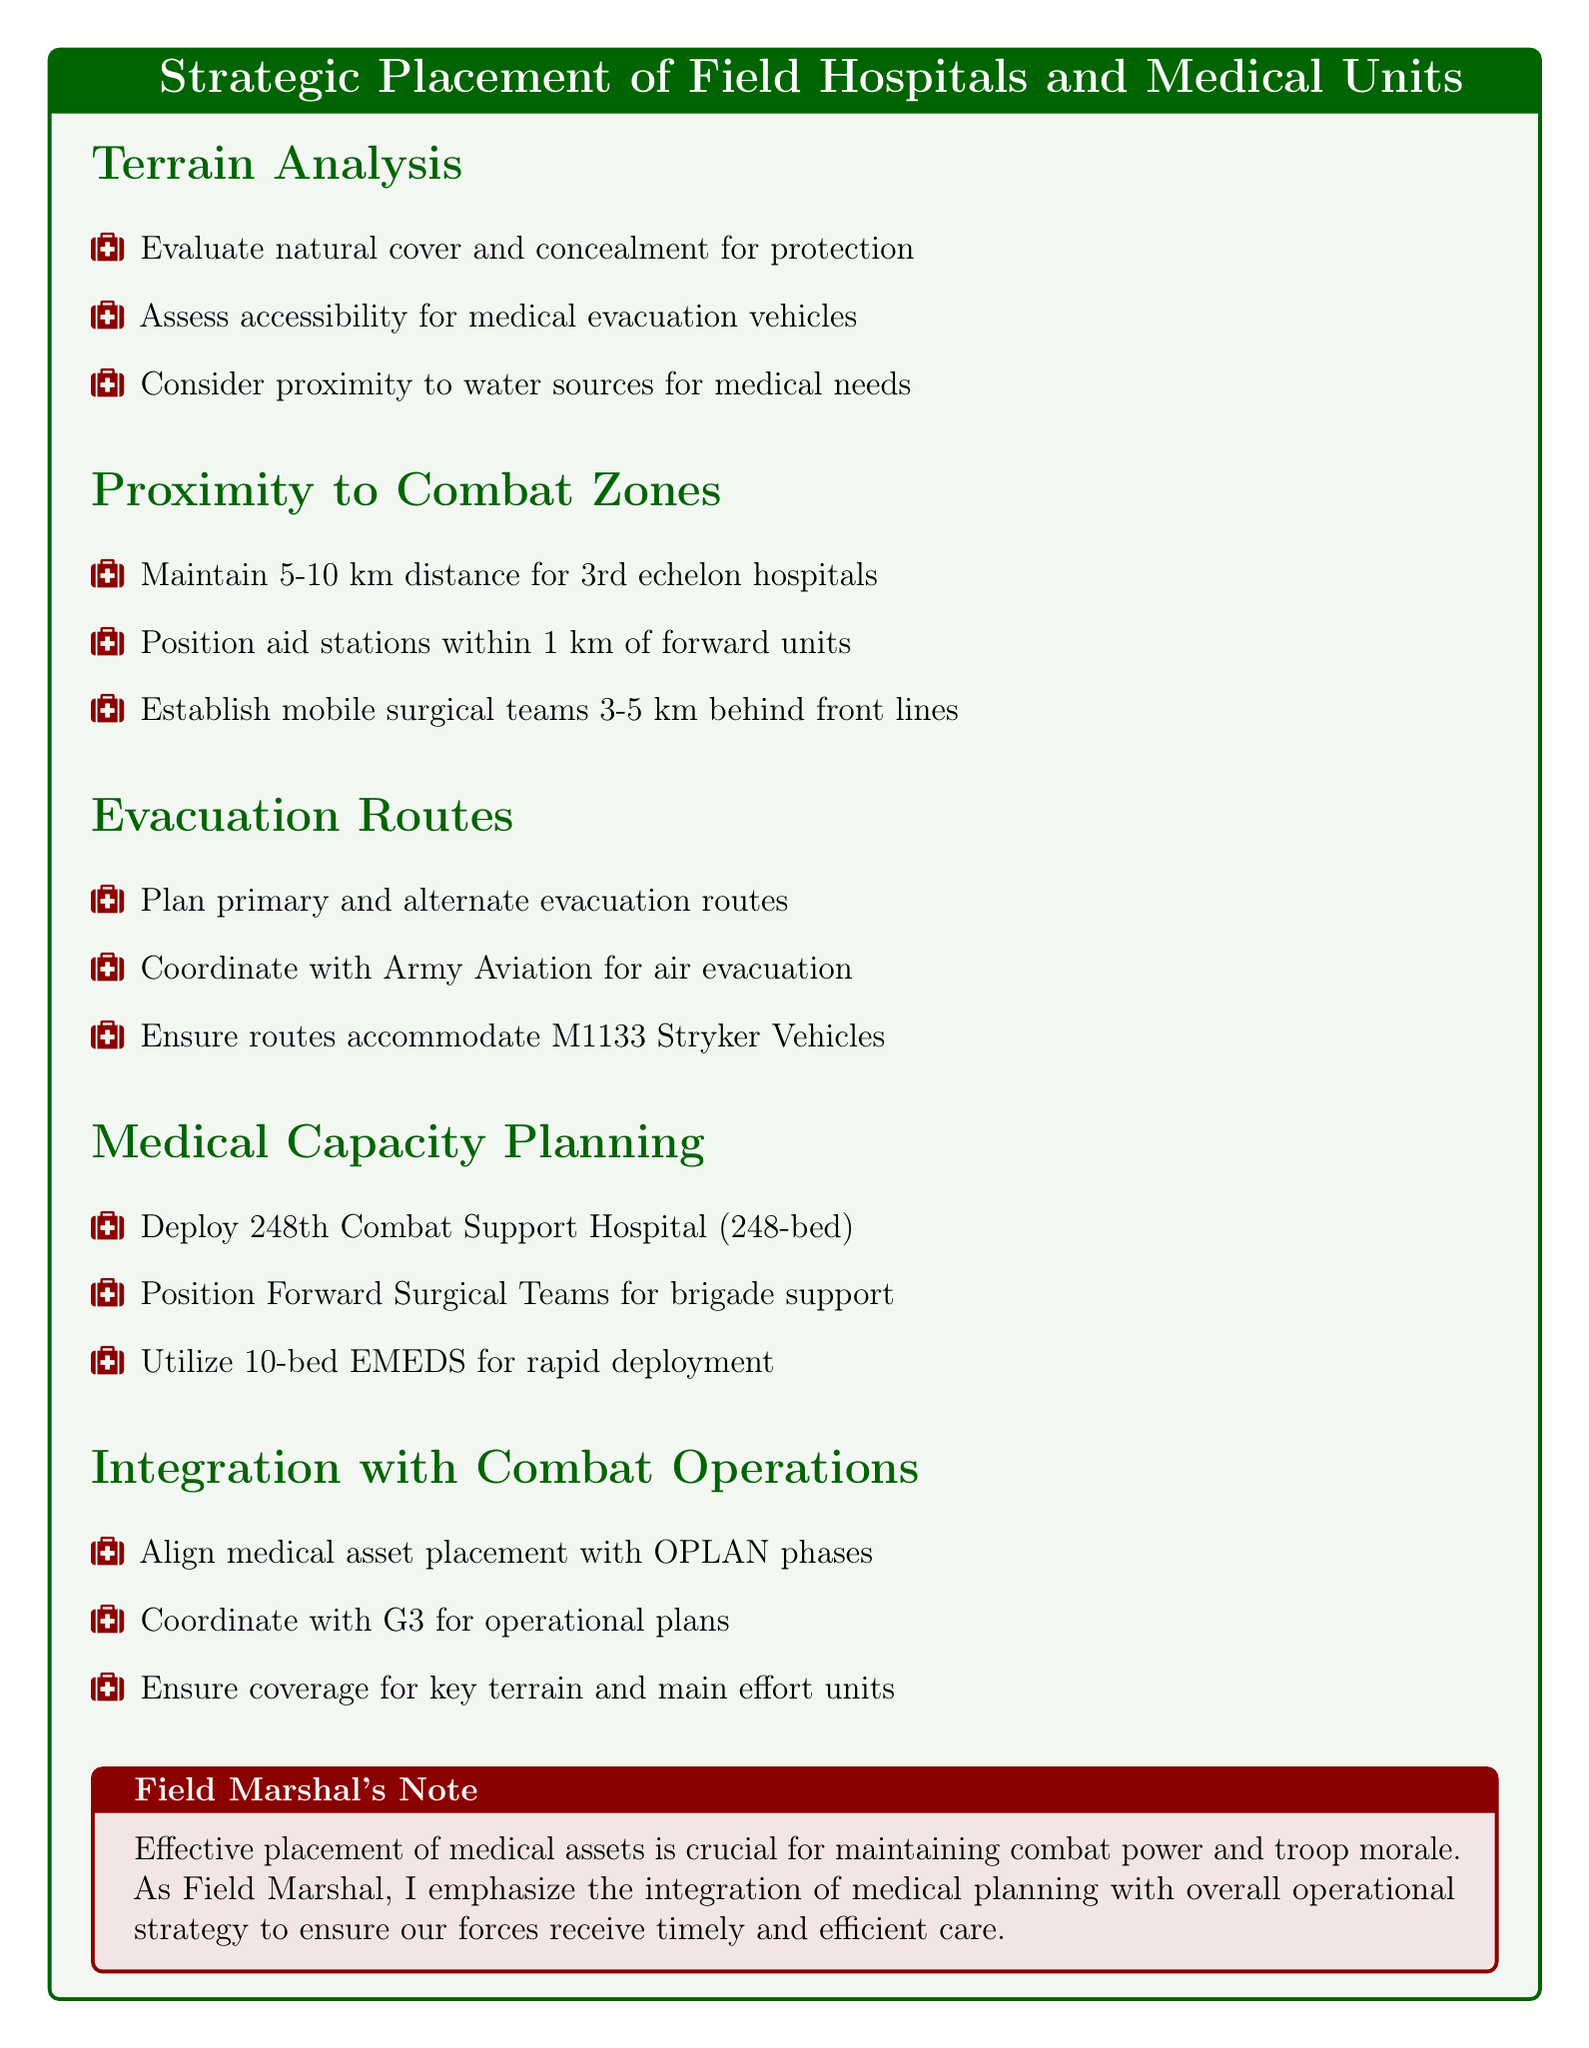What is the recommended distance for 3rd echelon hospitals? The document states that 3rd echelon hospitals should maintain a distance of 5-10 km from the front lines.
Answer: 5-10 km What is the capacity of the 248th Combat Support Hospital? The 248th Combat Support Hospital has a 248-bed capability as mentioned in the medical capacity planning section.
Answer: 248 beds Where should aid stations be positioned for immediate care? Aid stations should be positioned within 1 km of forward units for immediate care.
Answer: Within 1 km What type of vehicles should evacuation routes accommodate? The evacuation routes should be able to accommodate M1133 Stryker Medical Evacuation Vehicles as specified in the evacuation routes section.
Answer: M1133 Stryker Vehicles How far behind the front lines should mobile surgical teams be established? Mobile surgical teams should be established 3-5 km behind the front lines according to the document.
Answer: 3-5 km What medical unit supports brigade combat teams? Forward Surgical Teams (FST) are positioned to support brigade combat teams as indicated in the medical capacity planning section.
Answer: Forward Surgical Teams (FST) What is the importance of medical asset placement according to the conclusion? The effective placement of medical assets is crucial for maintaining combat power and troop morale.
Answer: Combat power and troop morale With whom should medical asset placement be aligned? Medical asset placement should be aligned with OPLAN phases, as noted in the integration with combat operations section.
Answer: OPLAN phases 